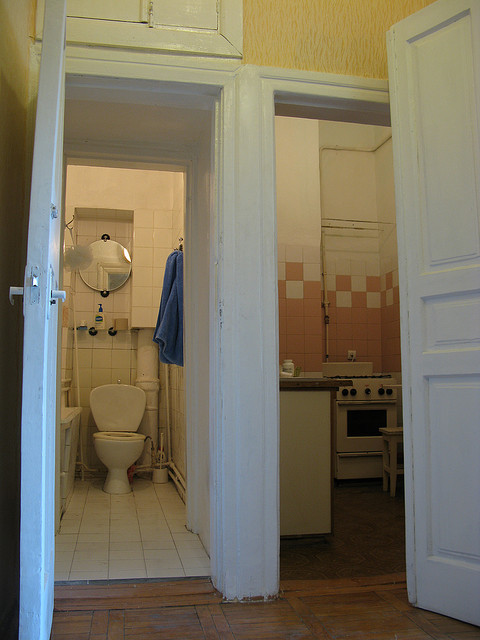Can you tell me about the color scheme used in this space? The space utilizes a simple yet contrasting color scheme comprised of predominantly light tones, accented by the pink tiles in the kitchen. The use of white on the doors and ceiling helps to brighten the space, while the tiles add a touch of color and personality. 